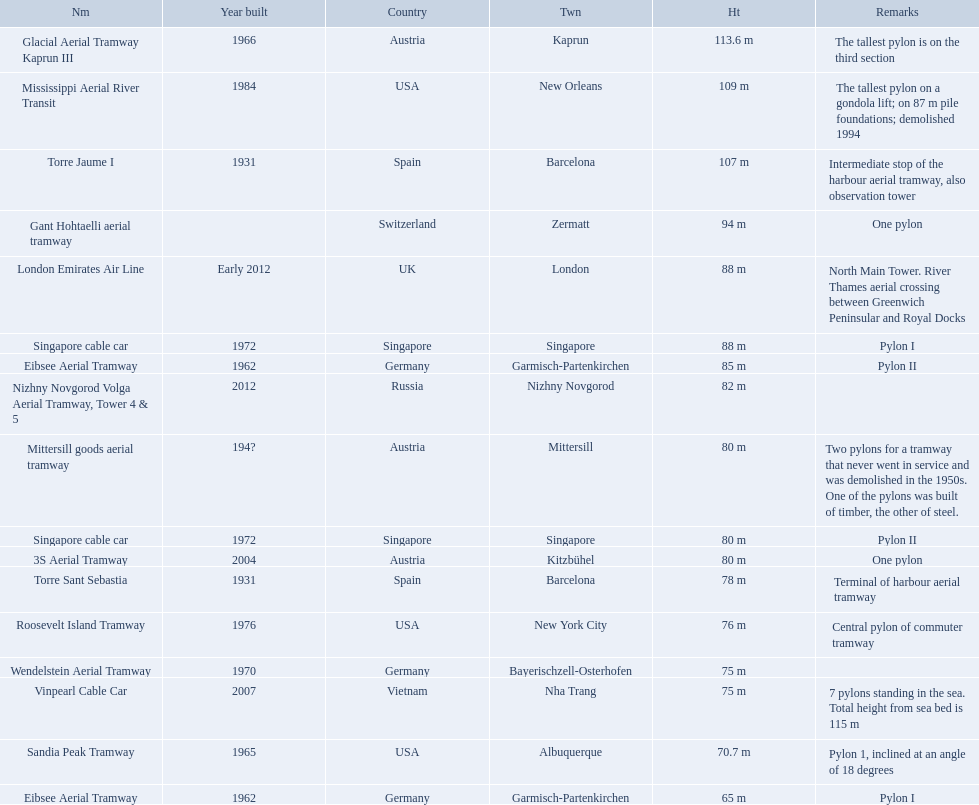Which aerial lifts are over 100 meters tall? Glacial Aerial Tramway Kaprun III, Mississippi Aerial River Transit, Torre Jaume I. Which of those was built last? Mississippi Aerial River Transit. And what is its total height? 109 m. 